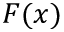Convert formula to latex. <formula><loc_0><loc_0><loc_500><loc_500>F ( x )</formula> 